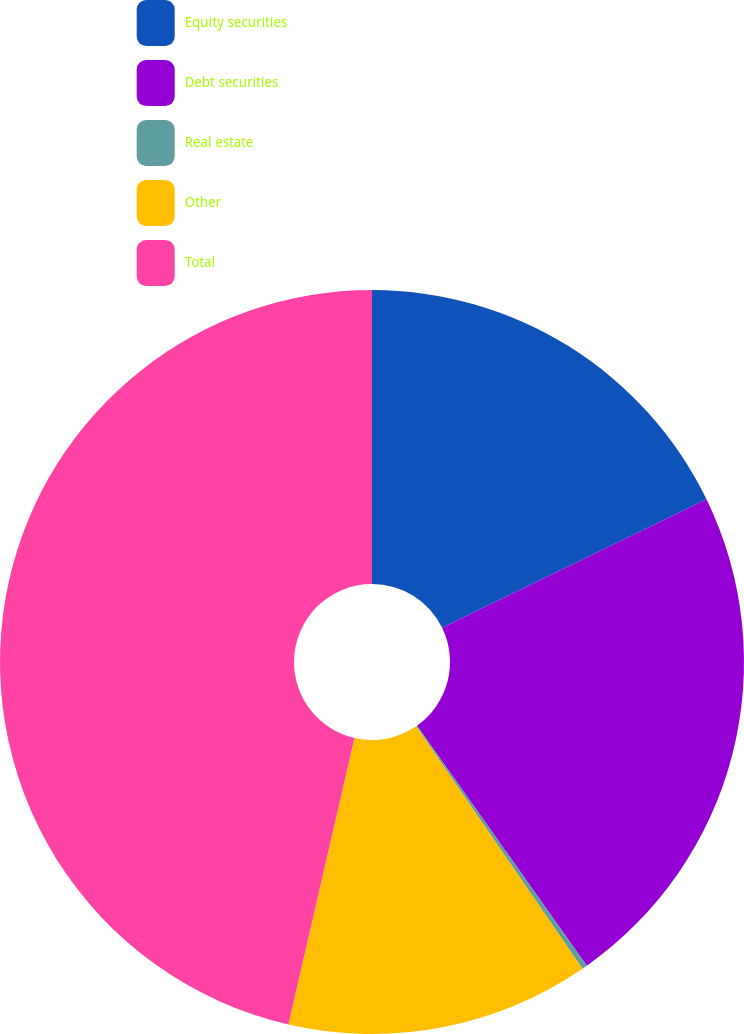Convert chart to OTSL. <chart><loc_0><loc_0><loc_500><loc_500><pie_chart><fcel>Equity securities<fcel>Debt securities<fcel>Real estate<fcel>Other<fcel>Total<nl><fcel>17.79%<fcel>22.41%<fcel>0.23%<fcel>13.18%<fcel>46.39%<nl></chart> 